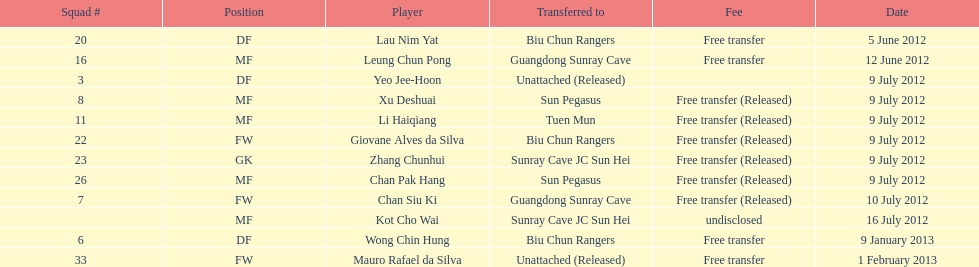How many total players were transferred to sun pegasus? 2. 